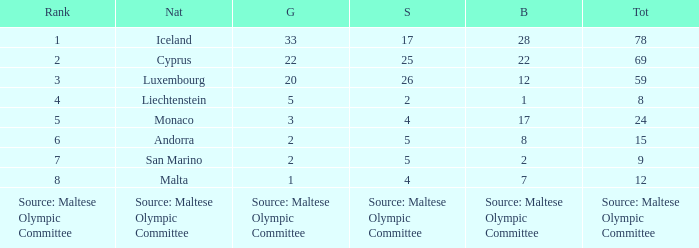What nation has 28 bronze medals? Iceland. 